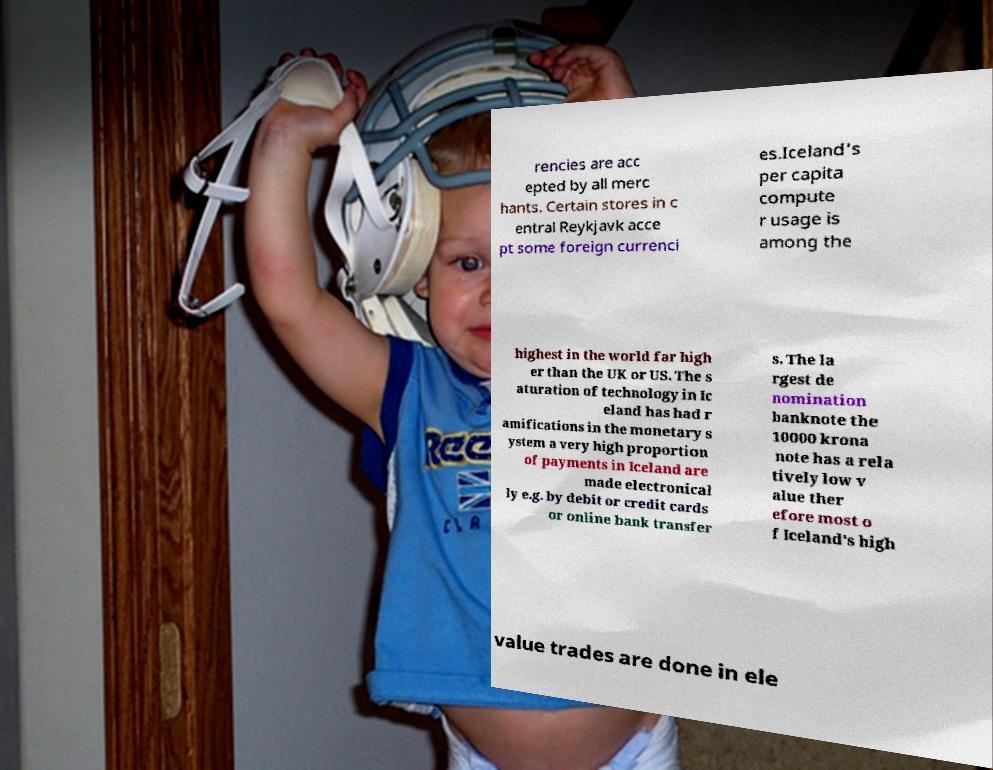Can you accurately transcribe the text from the provided image for me? rencies are acc epted by all merc hants. Certain stores in c entral Reykjavk acce pt some foreign currenci es.Iceland's per capita compute r usage is among the highest in the world far high er than the UK or US. The s aturation of technology in Ic eland has had r amifications in the monetary s ystem a very high proportion of payments in Iceland are made electronical ly e.g. by debit or credit cards or online bank transfer s. The la rgest de nomination banknote the 10000 krona note has a rela tively low v alue ther efore most o f Iceland's high value trades are done in ele 